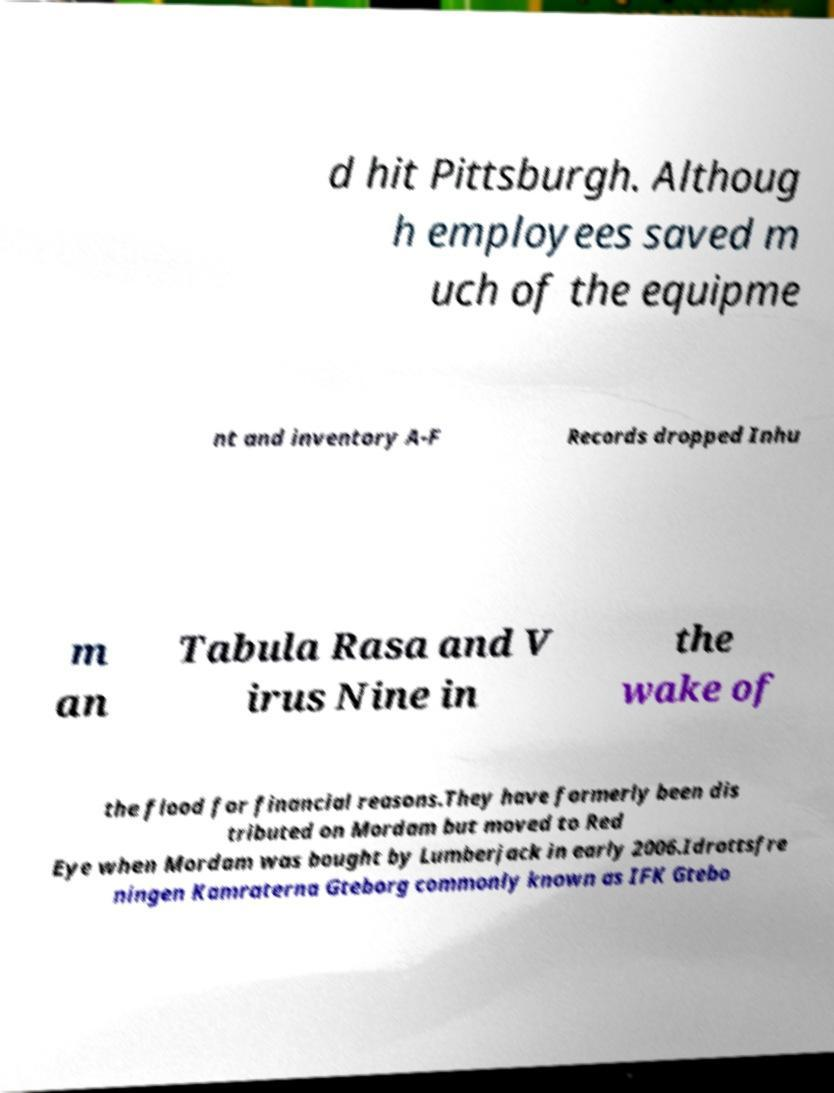Could you extract and type out the text from this image? d hit Pittsburgh. Althoug h employees saved m uch of the equipme nt and inventory A-F Records dropped Inhu m an Tabula Rasa and V irus Nine in the wake of the flood for financial reasons.They have formerly been dis tributed on Mordam but moved to Red Eye when Mordam was bought by Lumberjack in early 2006.Idrottsfre ningen Kamraterna Gteborg commonly known as IFK Gtebo 